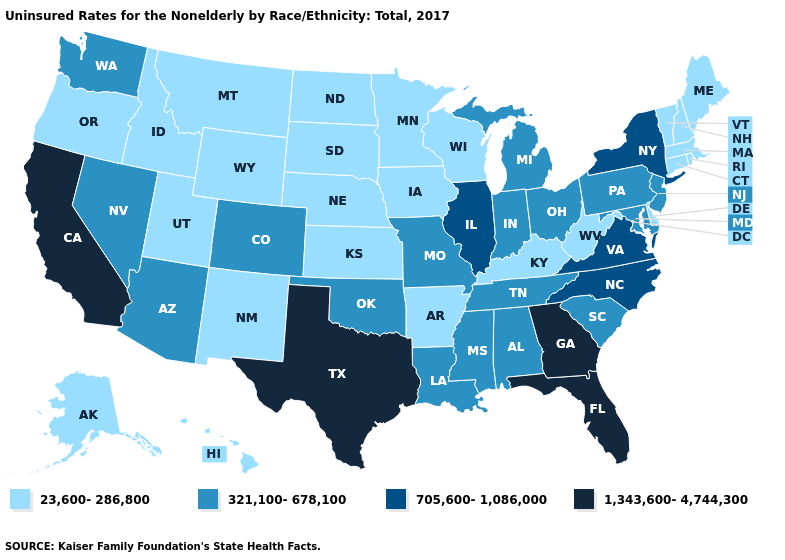Name the states that have a value in the range 321,100-678,100?
Concise answer only. Alabama, Arizona, Colorado, Indiana, Louisiana, Maryland, Michigan, Mississippi, Missouri, Nevada, New Jersey, Ohio, Oklahoma, Pennsylvania, South Carolina, Tennessee, Washington. What is the value of New Mexico?
Concise answer only. 23,600-286,800. Name the states that have a value in the range 705,600-1,086,000?
Quick response, please. Illinois, New York, North Carolina, Virginia. Name the states that have a value in the range 23,600-286,800?
Give a very brief answer. Alaska, Arkansas, Connecticut, Delaware, Hawaii, Idaho, Iowa, Kansas, Kentucky, Maine, Massachusetts, Minnesota, Montana, Nebraska, New Hampshire, New Mexico, North Dakota, Oregon, Rhode Island, South Dakota, Utah, Vermont, West Virginia, Wisconsin, Wyoming. What is the value of Georgia?
Keep it brief. 1,343,600-4,744,300. Does North Carolina have the highest value in the South?
Short answer required. No. Does the map have missing data?
Answer briefly. No. How many symbols are there in the legend?
Concise answer only. 4. Which states have the highest value in the USA?
Keep it brief. California, Florida, Georgia, Texas. Which states have the highest value in the USA?
Keep it brief. California, Florida, Georgia, Texas. Does Michigan have the highest value in the MidWest?
Answer briefly. No. Name the states that have a value in the range 705,600-1,086,000?
Be succinct. Illinois, New York, North Carolina, Virginia. Name the states that have a value in the range 321,100-678,100?
Give a very brief answer. Alabama, Arizona, Colorado, Indiana, Louisiana, Maryland, Michigan, Mississippi, Missouri, Nevada, New Jersey, Ohio, Oklahoma, Pennsylvania, South Carolina, Tennessee, Washington. What is the value of Pennsylvania?
Answer briefly. 321,100-678,100. Which states hav the highest value in the West?
Concise answer only. California. 